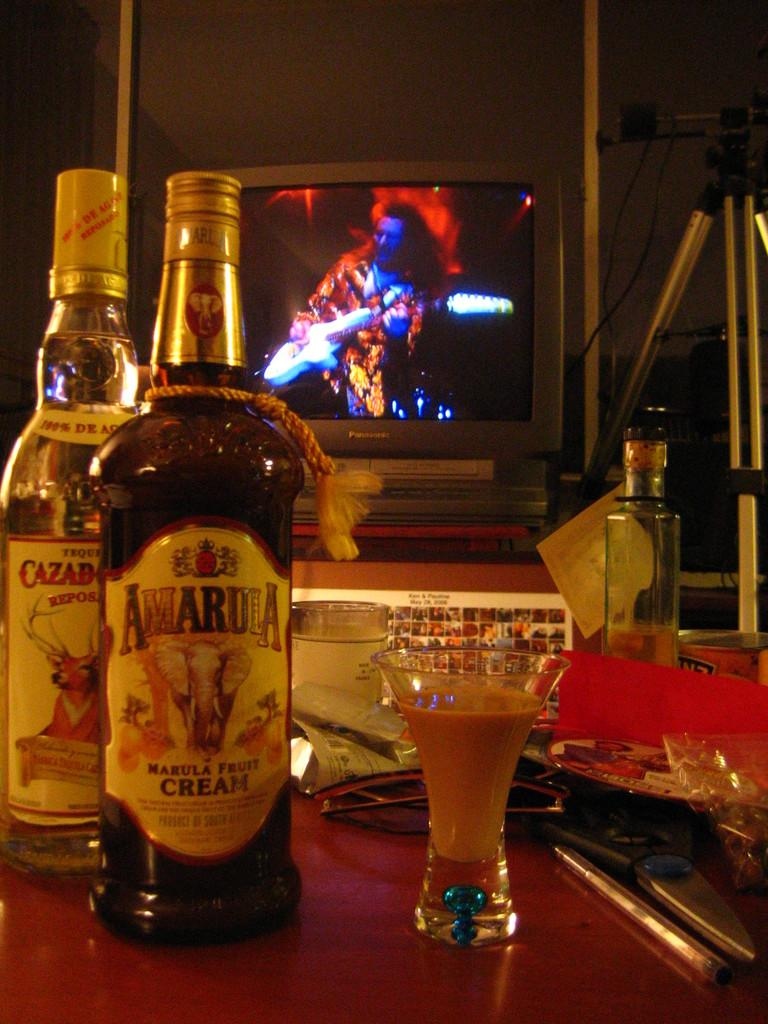<image>
Describe the image concisely. A bottle of tequilla and a bottle of Awardia fruit cream are on a bar. 